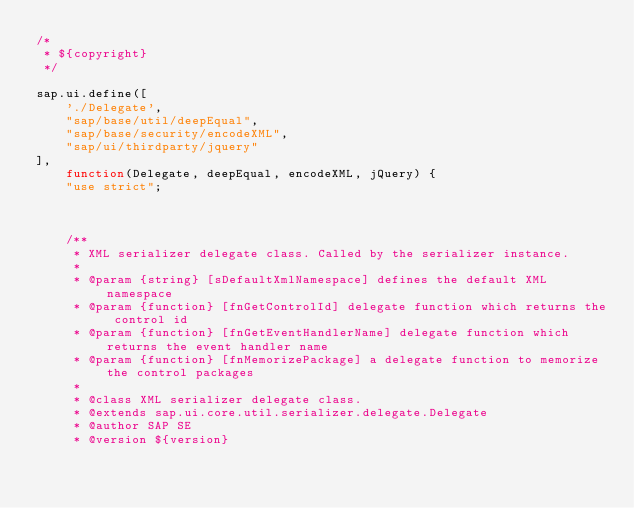Convert code to text. <code><loc_0><loc_0><loc_500><loc_500><_JavaScript_>/*
 * ${copyright}
 */

sap.ui.define([
	'./Delegate',
	"sap/base/util/deepEqual",
	"sap/base/security/encodeXML",
	"sap/ui/thirdparty/jquery"
],
	function(Delegate, deepEqual, encodeXML, jQuery) {
	"use strict";



	/**
	 * XML serializer delegate class. Called by the serializer instance.
	 *
	 * @param {string} [sDefaultXmlNamespace] defines the default XML namespace
	 * @param {function} [fnGetControlId] delegate function which returns the control id
	 * @param {function} [fnGetEventHandlerName] delegate function which returns the event handler name
	 * @param {function} [fnMemorizePackage] a delegate function to memorize the control packages
	 *
	 * @class XML serializer delegate class.
	 * @extends sap.ui.core.util.serializer.delegate.Delegate
	 * @author SAP SE
	 * @version ${version}</code> 